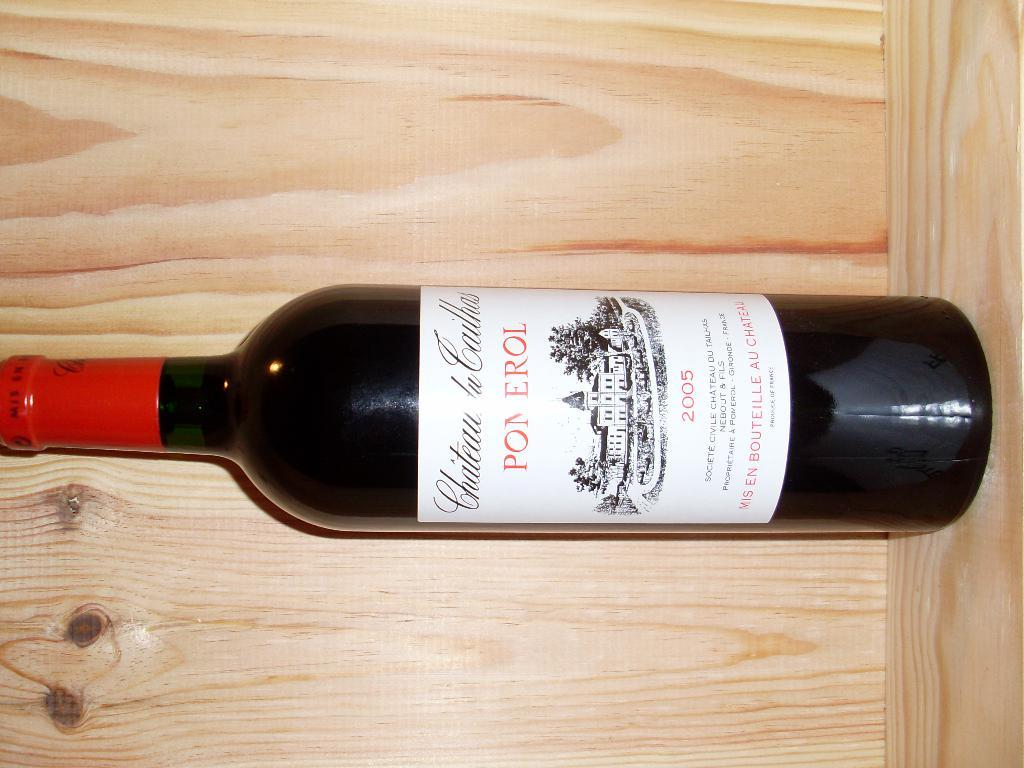Provide a one-sentence caption for the provided image. A bottle of Pom Erol wine with a red label on the top. 